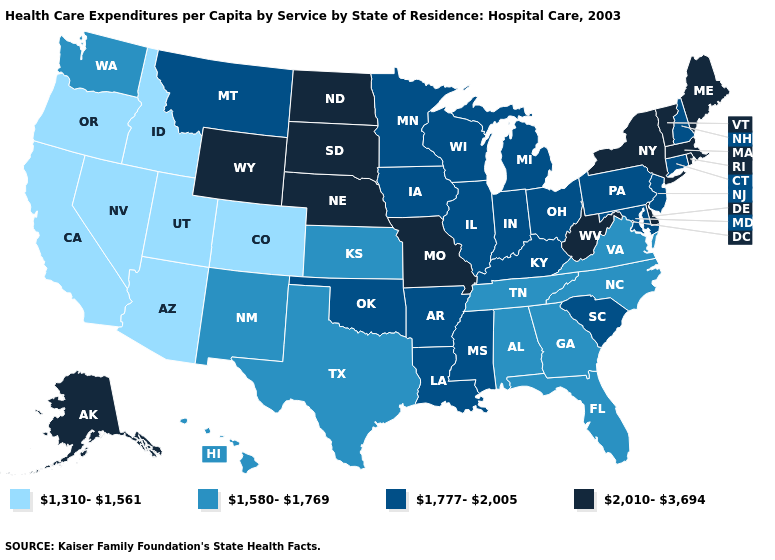What is the value of New Mexico?
Give a very brief answer. 1,580-1,769. What is the value of Maryland?
Be succinct. 1,777-2,005. Does New Jersey have the same value as Tennessee?
Be succinct. No. Does Delaware have a higher value than Maryland?
Be succinct. Yes. What is the value of Iowa?
Concise answer only. 1,777-2,005. How many symbols are there in the legend?
Concise answer only. 4. Is the legend a continuous bar?
Concise answer only. No. Name the states that have a value in the range 1,580-1,769?
Quick response, please. Alabama, Florida, Georgia, Hawaii, Kansas, New Mexico, North Carolina, Tennessee, Texas, Virginia, Washington. Which states have the lowest value in the West?
Concise answer only. Arizona, California, Colorado, Idaho, Nevada, Oregon, Utah. Name the states that have a value in the range 1,777-2,005?
Concise answer only. Arkansas, Connecticut, Illinois, Indiana, Iowa, Kentucky, Louisiana, Maryland, Michigan, Minnesota, Mississippi, Montana, New Hampshire, New Jersey, Ohio, Oklahoma, Pennsylvania, South Carolina, Wisconsin. What is the value of Wyoming?
Be succinct. 2,010-3,694. Which states hav the highest value in the West?
Concise answer only. Alaska, Wyoming. Is the legend a continuous bar?
Be succinct. No. What is the highest value in the USA?
Be succinct. 2,010-3,694. Name the states that have a value in the range 1,777-2,005?
Concise answer only. Arkansas, Connecticut, Illinois, Indiana, Iowa, Kentucky, Louisiana, Maryland, Michigan, Minnesota, Mississippi, Montana, New Hampshire, New Jersey, Ohio, Oklahoma, Pennsylvania, South Carolina, Wisconsin. 